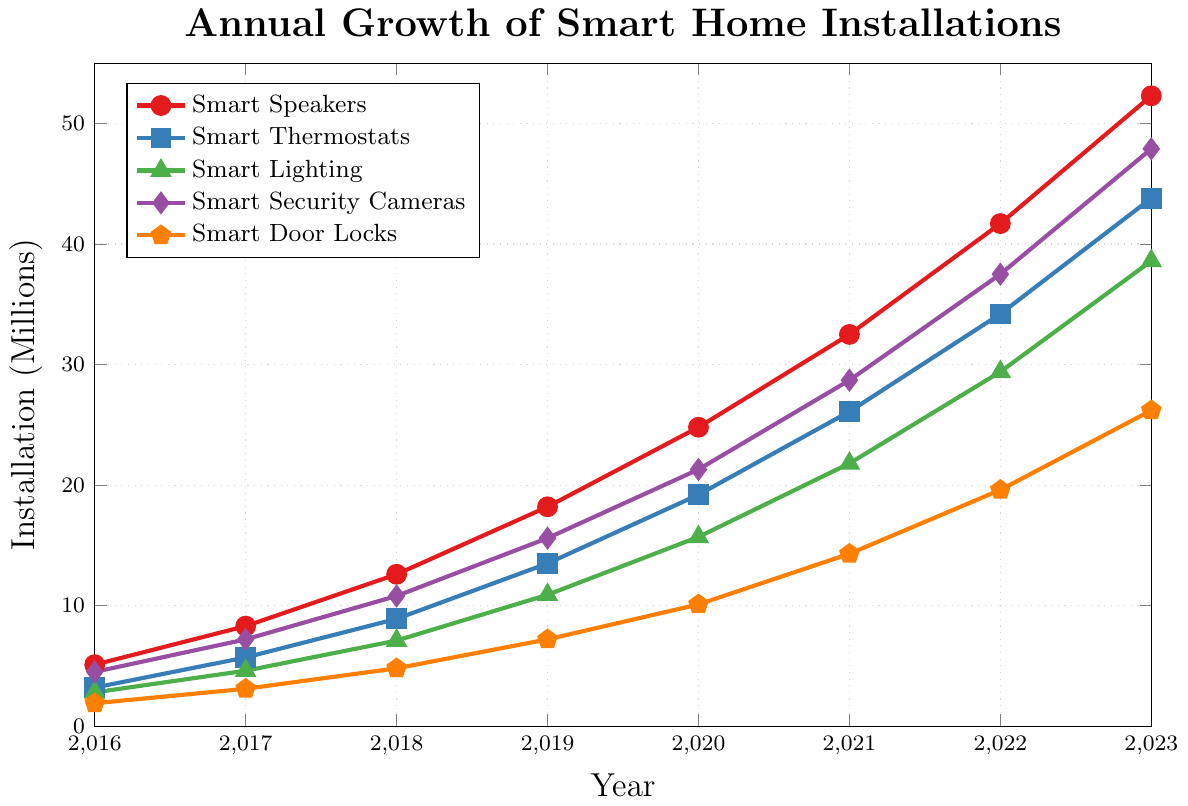What was the growth in smart speaker installations from 2016 to 2017? To find the growth, subtract the number of installations in 2016 from the number in 2017. Growth = 8.3 - 5.1 = 3.2 million.
Answer: 3.2 million Which device had the highest installations in 2023? Look at the data points for 2023 and compare the installations of each device. Smart Speakers: 52.3, Smart Thermostats: 43.8, Smart Lighting: 38.6, Smart Security Cameras: 47.9, Smart Door Locks: 26.2. The highest is Smart Speakers with 52.3 million installations.
Answer: Smart Speakers Which device showed the slowest growth between the years 2016 and 2017? Calculate the differences for each device between 2016 and 2017. Smart Speakers: 8.3 - 5.1 = 3.2, Smart Thermostats: 5.7 - 3.2 = 2.5, Smart Lighting: 4.6 - 2.8 = 1.8, Smart Security Cameras: 7.2 - 4.5 = 2.7, Smart Door Locks: 3.1 - 1.9 = 1.2. The smallest difference is for Smart Door Locks with 1.2 million.
Answer: Smart Door Locks In which year did Smart Security Cameras surpass 20 million installations? Examine the data points for Smart Security Cameras and find the first year the installations exceeded 20 million. The data shows this happened in 2020 with 21.3 million installations.
Answer: 2020 What is the total number of Smart Lighting installations over the years 2019 and 2020 combined? Sum the installations for Smart Lighting in 2019 and 2020. Total = 10.9 (2019) + 15.7 (2020) = 26.6 million.
Answer: 26.6 million Which year saw the steepest increase in Smart Thermostat installations? To find the steepest increase, calculate the difference in Smart Thermostat installations year-over-year and identify the largest increase. The differences are: (2017-2016) = 2.5, (2018-2017) = 3.2, (2019-2018) = 4.6, (2020-2019) = 5.7, (2021-2020) = 6.9, (2022-2021) = 8.1, (2023-2022) = 9.6. The steepest increase occurred from 2022 to 2023 with 9.6 million.
Answer: 2022 to 2023 How many more installations did Smart Speakers have compared to Smart Door Locks in 2023? Subtract the number of Smart Door Locks installations from the number of Smart Speaker installations in 2023. Difference = 52.3 - 26.2 = 26.1 million.
Answer: 26.1 million What is the average annual growth of Smart Thermostats from 2016 to 2023? To find the average annual growth, first determine the total growth and then divide by the number of years. Growth = 43.8 (2023) - 3.2 (2016) = 40.6 million. Number of years = 2023-2016 = 7. Average annual growth = 40.6 / 7 ≈ 5.8 million installations per year.
Answer: 5.8 million Which device had the closest number of installations to Smart Lighting in 2019? Compare the installations of other devices to Smart Lighting in 2019, which had 10.9 million. Smart Speakers: 18.2, Smart Thermostats: 13.5, Smart Security Cameras: 15.6, Smart Door Locks: 7.2. The closest is Smart Thermostats with 13.5 million installations.
Answer: Smart Thermostats 